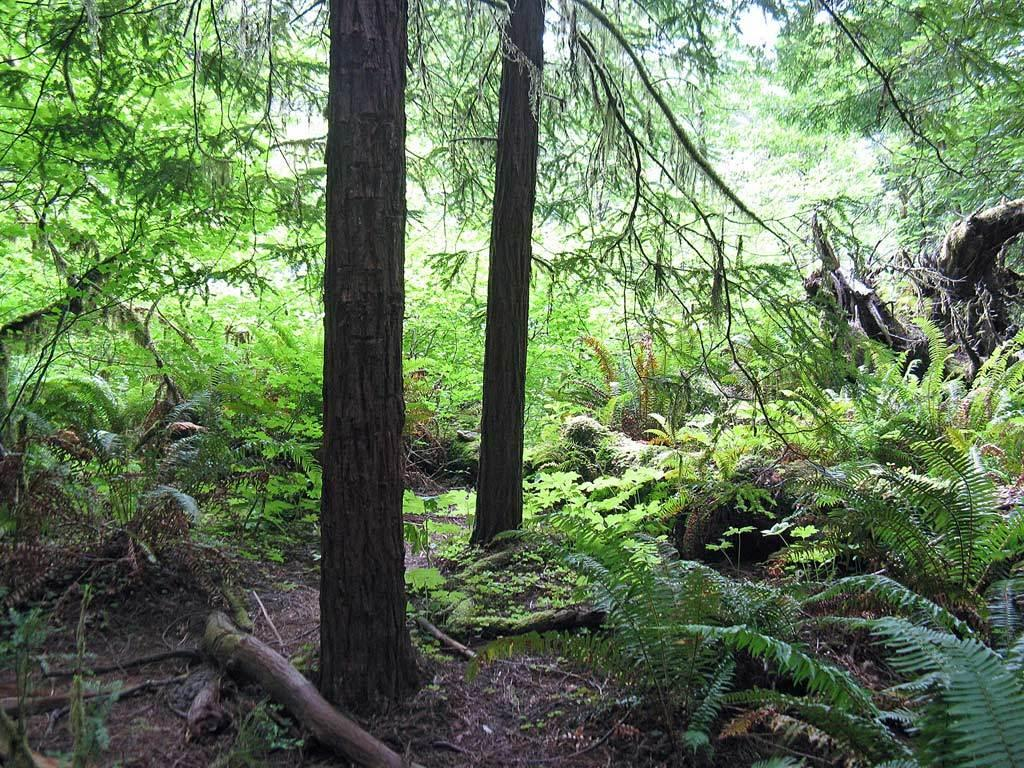What type of environment is shown in the image? The image depicts a forest. What are the main features of the forest? There are trees in the image, including tree trunks and tree branches. What is at the bottom of the image? There is mud at the bottom of the image. What type of needle can be seen sewing a piece of clothing in the image? There is no needle or clothing present in the image; it depicts a forest with trees, tree trunks, tree branches, and mud. 